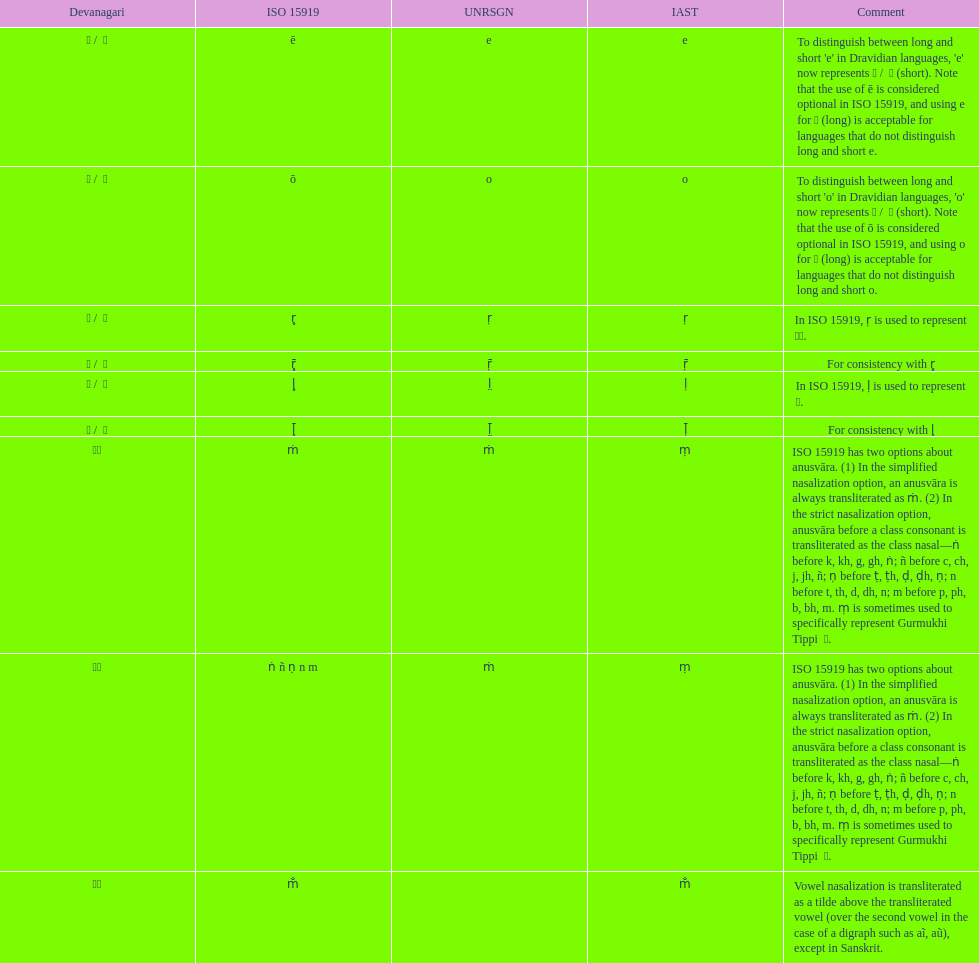Which devanagari symbol corresponds to this iast character: o? ओ / ो. 